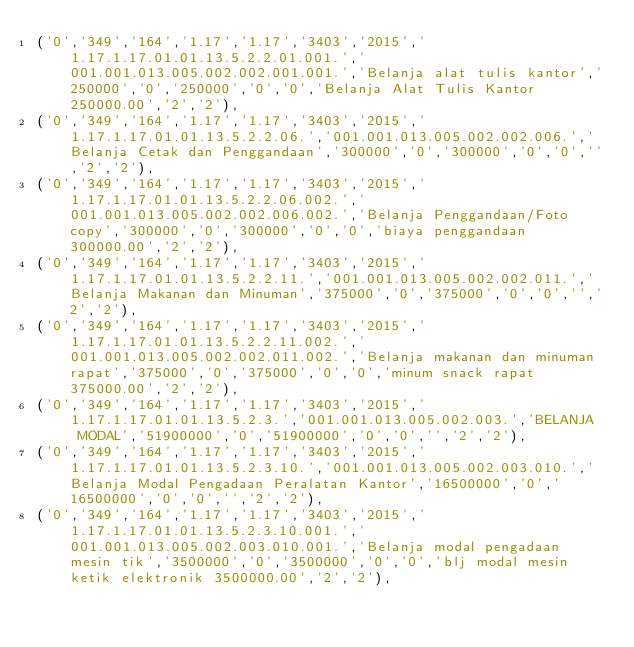<code> <loc_0><loc_0><loc_500><loc_500><_SQL_>('0','349','164','1.17','1.17','3403','2015','1.17.1.17.01.01.13.5.2.2.01.001.','001.001.013.005.002.002.001.001.','Belanja alat tulis kantor','250000','0','250000','0','0','Belanja Alat Tulis Kantor 250000.00','2','2'),
('0','349','164','1.17','1.17','3403','2015','1.17.1.17.01.01.13.5.2.2.06.','001.001.013.005.002.002.006.','Belanja Cetak dan Penggandaan','300000','0','300000','0','0','','2','2'),
('0','349','164','1.17','1.17','3403','2015','1.17.1.17.01.01.13.5.2.2.06.002.','001.001.013.005.002.002.006.002.','Belanja Penggandaan/Foto copy','300000','0','300000','0','0','biaya penggandaan 300000.00','2','2'),
('0','349','164','1.17','1.17','3403','2015','1.17.1.17.01.01.13.5.2.2.11.','001.001.013.005.002.002.011.','Belanja Makanan dan Minuman','375000','0','375000','0','0','','2','2'),
('0','349','164','1.17','1.17','3403','2015','1.17.1.17.01.01.13.5.2.2.11.002.','001.001.013.005.002.002.011.002.','Belanja makanan dan minuman rapat','375000','0','375000','0','0','minum snack rapat 375000.00','2','2'),
('0','349','164','1.17','1.17','3403','2015','1.17.1.17.01.01.13.5.2.3.','001.001.013.005.002.003.','BELANJA  MODAL','51900000','0','51900000','0','0','','2','2'),
('0','349','164','1.17','1.17','3403','2015','1.17.1.17.01.01.13.5.2.3.10.','001.001.013.005.002.003.010.','Belanja Modal Pengadaan Peralatan Kantor','16500000','0','16500000','0','0','','2','2'),
('0','349','164','1.17','1.17','3403','2015','1.17.1.17.01.01.13.5.2.3.10.001.','001.001.013.005.002.003.010.001.','Belanja modal pengadaan mesin tik','3500000','0','3500000','0','0','blj modal mesin ketik elektronik 3500000.00','2','2'),</code> 